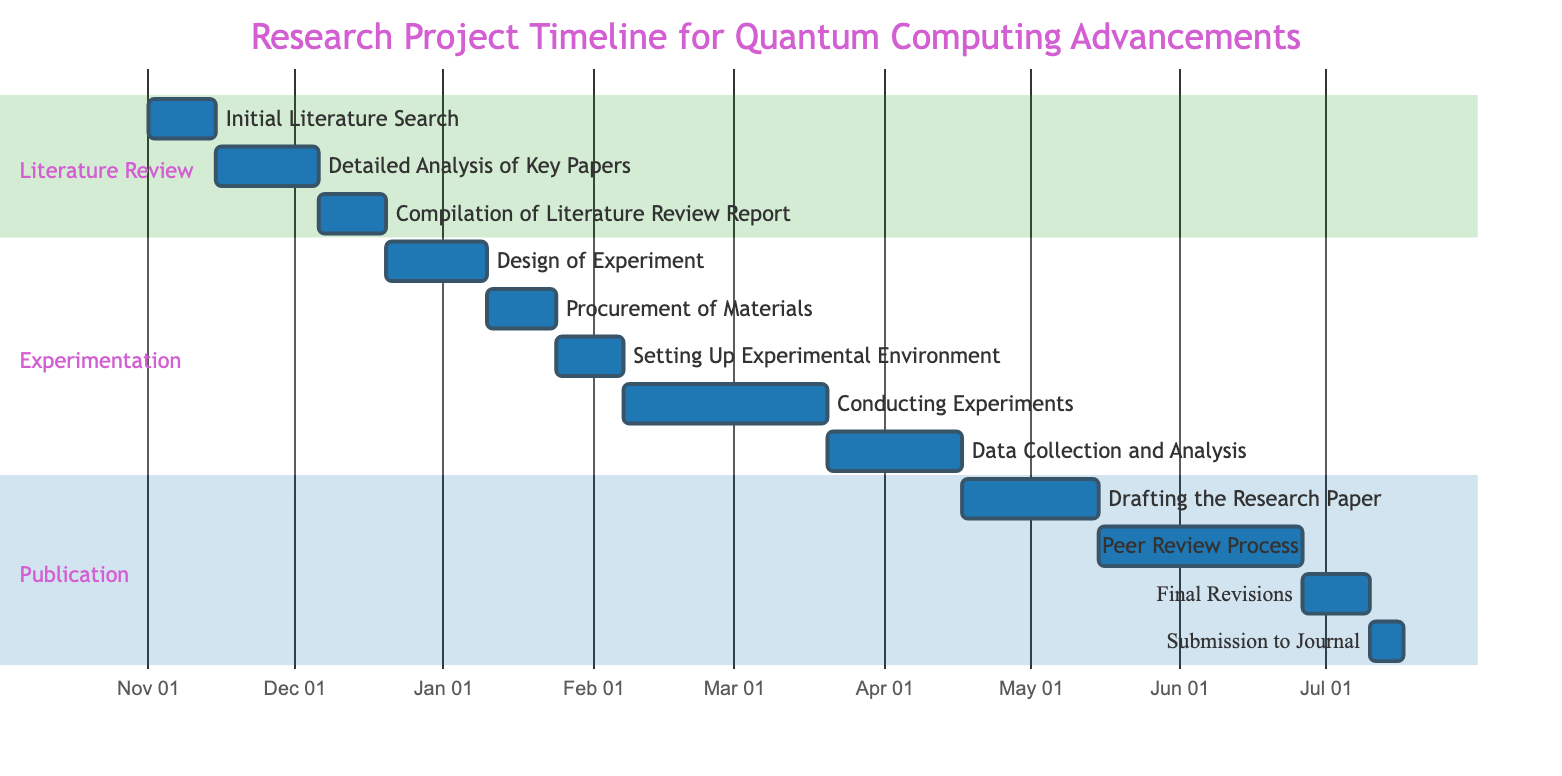What is the duration of the "Detailed Analysis of Key Papers" task? The task "Detailed Analysis of Key Papers" is shown to have a duration of 3 weeks on the Gantt chart.
Answer: 3 weeks What is the start date of the "Conducting Experiments" task? The "Conducting Experiments" task begins after "Setting Up Experimental Environment," which ends on 2024-02-06, so it starts on 2024-02-07.
Answer: 2024-02-07 How many weeks are allocated for the "Peer Review Process"? The "Peer Review Process" is indicated to have a duration of 6 weeks on the diagram.
Answer: 6 weeks What is the end date of the "Submission to Journal" task? The task "Submission to Journal" starts after "Final Revisions," which ends on 2024-07-09, placing its end date on 2024-07-16.
Answer: 2024-07-16 Which task has the longest duration in the project? The "Conducting Experiments" task has a duration of 6 weeks, which is the longest compared to other tasks in the project.
Answer: Conducting Experiments How many tasks are there in the "Literature Review" phase? Counting the tasks listed under the "Literature Review" phase, there are a total of 3 tasks: "Initial Literature Search," "Detailed Analysis of Key Papers," and "Compilation of Literature Review Report."
Answer: 3 tasks When does the "Drafting the Research Paper" task start? This task, "Drafting the Research Paper," begins after "Data Collection and Analysis," which ends on 2024-04-16, indicating it starts on 2024-04-17.
Answer: 2024-04-17 What is the dependency of "Setting Up Experimental Environment"? The task "Setting Up Experimental Environment" depends on the completion of "Procurement of Materials," indicating it cannot start until that task is finished.
Answer: Procurement of Materials How many phases are represented in the Gantt chart? The Gantt chart displays 3 phases: Literature Review, Experimentation, and Publication.
Answer: 3 phases 